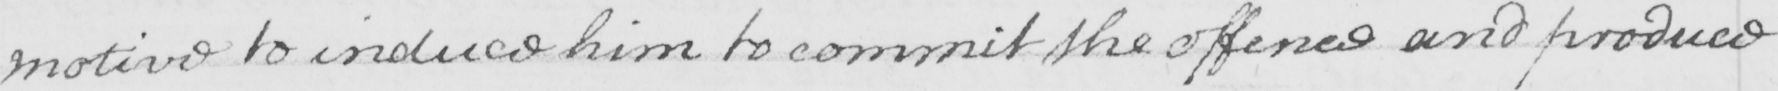Please provide the text content of this handwritten line. motive to induce him to commit the offence and produce 